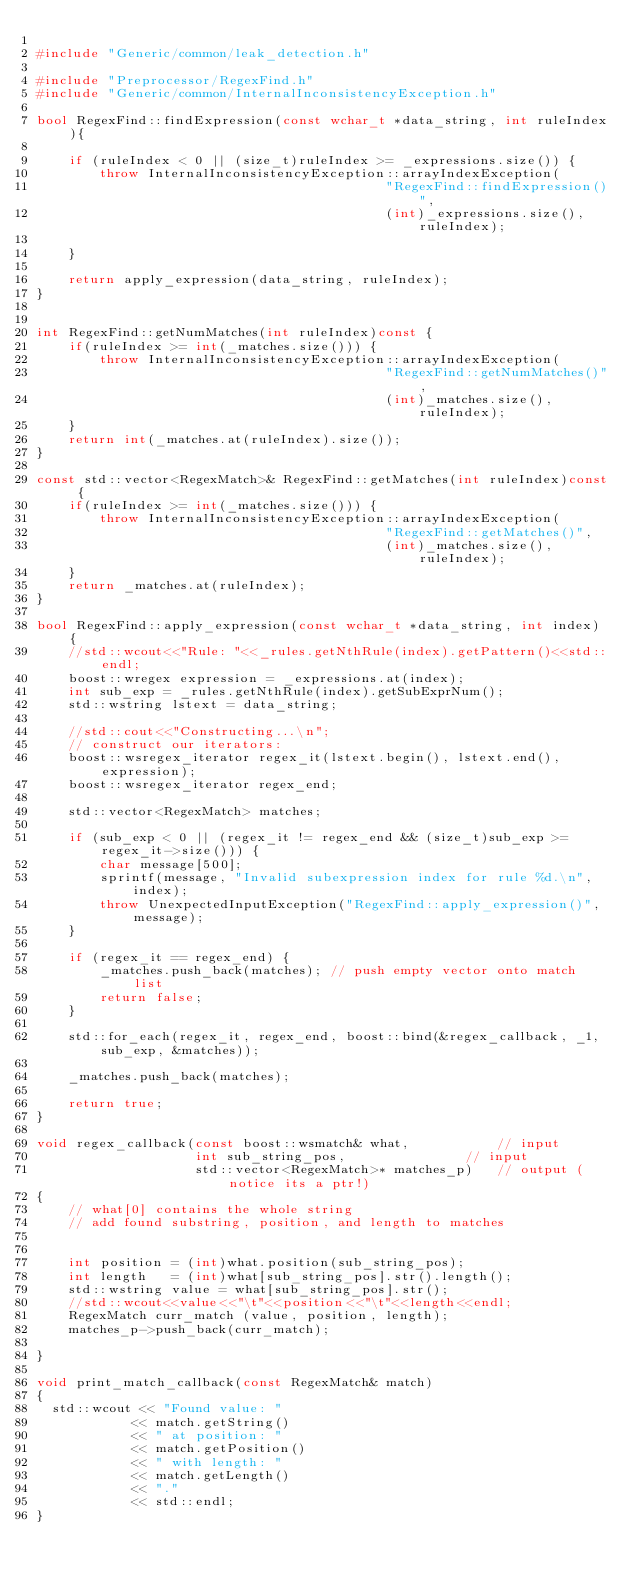<code> <loc_0><loc_0><loc_500><loc_500><_C++_>
#include "Generic/common/leak_detection.h"

#include "Preprocessor/RegexFind.h"
#include "Generic/common/InternalInconsistencyException.h"

bool RegexFind::findExpression(const wchar_t *data_string, int ruleIndex){
	
	if (ruleIndex < 0 || (size_t)ruleIndex >= _expressions.size()) {
		throw InternalInconsistencyException::arrayIndexException(
											"RegexFind::findExpression()",
											(int)_expressions.size(), ruleIndex);
					
	}

	return apply_expression(data_string, ruleIndex);
}


int RegexFind::getNumMatches(int ruleIndex)const {
	if(ruleIndex >= int(_matches.size())) {
		throw InternalInconsistencyException::arrayIndexException(
											"RegexFind::getNumMatches()",
											(int)_matches.size(), ruleIndex);
	}
	return int(_matches.at(ruleIndex).size());
}

const std::vector<RegexMatch>& RegexFind::getMatches(int ruleIndex)const {
	if(ruleIndex >= int(_matches.size())) {
		throw InternalInconsistencyException::arrayIndexException(
											"RegexFind::getMatches()",
											(int)_matches.size(), ruleIndex);
	}
	return _matches.at(ruleIndex);
}

bool RegexFind::apply_expression(const wchar_t *data_string, int index) {
	//std::wcout<<"Rule: "<<_rules.getNthRule(index).getPattern()<<std::endl;
	boost::wregex expression = _expressions.at(index);
	int sub_exp = _rules.getNthRule(index).getSubExprNum();
	std::wstring lstext = data_string;

	//std::cout<<"Constructing...\n";
    // construct our iterators:
    boost::wsregex_iterator regex_it(lstext.begin(), lstext.end(), expression);
    boost::wsregex_iterator regex_end;

    std::vector<RegexMatch> matches;

	if (sub_exp < 0 || (regex_it != regex_end && (size_t)sub_exp >= regex_it->size())) {
		char message[500];
		sprintf(message, "Invalid subexpression index for rule %d.\n", index);
		throw UnexpectedInputException("RegexFind::apply_expression()", message);
	}

	if (regex_it == regex_end) {
		_matches.push_back(matches); // push empty vector onto match list
		return false;
	}

	std::for_each(regex_it, regex_end, boost::bind(&regex_callback, _1, sub_exp, &matches));
   	
	_matches.push_back(matches);

	return true;
}

void regex_callback(const boost::wsmatch& what,           // input
                    int sub_string_pos,               // input
					std::vector<RegexMatch>* matches_p)   // output (notice its a ptr!)
{
	// what[0] contains the whole string
	// add found substring, position, and length to matches

	
	int position = (int)what.position(sub_string_pos);
	int length   = (int)what[sub_string_pos].str().length();
	std::wstring value = what[sub_string_pos].str();
	//std::wcout<<value<<"\t"<<position<<"\t"<<length<<endl;
	RegexMatch curr_match (value, position, length);
	matches_p->push_back(curr_match);
	
}

void print_match_callback(const RegexMatch& match)
{
  std::wcout << "Found value: " 
            << match.getString() 
            << " at position: " 
			<< match.getPosition() 
            << " with length: " 
            << match.getLength() 
            << "." 
            << std::endl;
}
</code> 